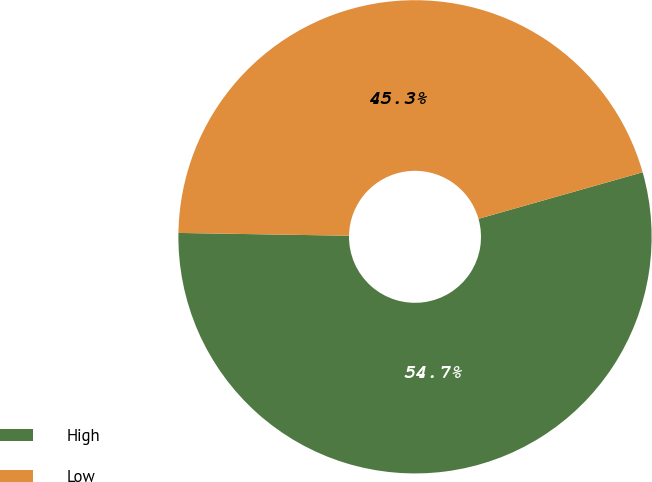Convert chart to OTSL. <chart><loc_0><loc_0><loc_500><loc_500><pie_chart><fcel>High<fcel>Low<nl><fcel>54.66%<fcel>45.34%<nl></chart> 